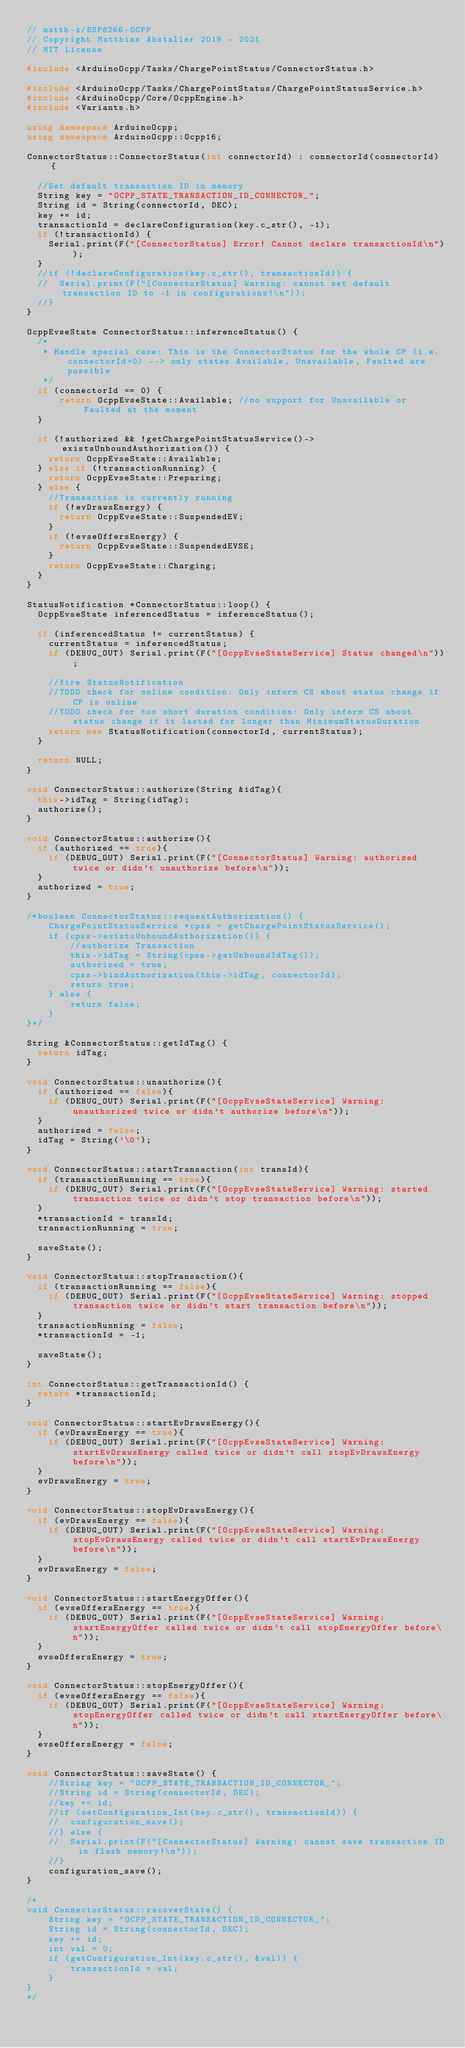Convert code to text. <code><loc_0><loc_0><loc_500><loc_500><_C++_>// matth-x/ESP8266-OCPP
// Copyright Matthias Akstaller 2019 - 2021
// MIT License

#include <ArduinoOcpp/Tasks/ChargePointStatus/ConnectorStatus.h>

#include <ArduinoOcpp/Tasks/ChargePointStatus/ChargePointStatusService.h>
#include <ArduinoOcpp/Core/OcppEngine.h>
#include <Variants.h>

using namespace ArduinoOcpp;
using namespace ArduinoOcpp::Ocpp16;

ConnectorStatus::ConnectorStatus(int connectorId) : connectorId(connectorId) {

  //Set default transaction ID in memory
  String key = "OCPP_STATE_TRANSACTION_ID_CONNECTOR_";
  String id = String(connectorId, DEC);
  key += id;
  transactionId = declareConfiguration(key.c_str(), -1);
  if (!transactionId) {
    Serial.print(F("[ConnectorStatus] Error! Cannot declare transactionId\n"));
  }
  //if (!declareConfiguration(key.c_str(), transactionId)) {
  //  Serial.print(F("[ConnectorStatus] Warning: cannot set default transaction ID to -1 in configurations!\n"));
  //}
}

OcppEvseState ConnectorStatus::inferenceStatus() {
  /*
   * Handle special case: This is the ConnectorStatus for the whole CP (i.e. connectorId=0) --> only states Available, Unavailable, Faulted are possible
   */
  if (connectorId == 0) {
      return OcppEvseState::Available; //no support for Unavailable or Faulted at the moment
  }

  if (!authorized && !getChargePointStatusService()->existsUnboundAuthorization()) {
    return OcppEvseState::Available;
  } else if (!transactionRunning) {
    return OcppEvseState::Preparing;
  } else {
    //Transaction is currently running
    if (!evDrawsEnergy) {
      return OcppEvseState::SuspendedEV;
    }
    if (!evseOffersEnergy) {
      return OcppEvseState::SuspendedEVSE;
    }
    return OcppEvseState::Charging;
  }
}

StatusNotification *ConnectorStatus::loop() {
  OcppEvseState inferencedStatus = inferenceStatus();
  
  if (inferencedStatus != currentStatus) {
    currentStatus = inferencedStatus;
    if (DEBUG_OUT) Serial.print(F("[OcppEvseStateService] Status changed\n"));

    //fire StatusNotification
    //TODO check for online condition: Only inform CS about status change if CP is online
    //TODO check for too short duration condition: Only inform CS about status change if it lasted for longer than MinimumStatusDuration
    return new StatusNotification(connectorId, currentStatus);
  }

  return NULL;
}

void ConnectorStatus::authorize(String &idTag){
  this->idTag = String(idTag);
  authorize();
}

void ConnectorStatus::authorize(){
  if (authorized == true){
    if (DEBUG_OUT) Serial.print(F("[ConnectorStatus] Warning: authorized twice or didn't unauthorize before\n"));
  }
  authorized = true;
}

/*boolean ConnectorStatus::requestAuthorization() {
    ChargePointStatusService *cpss = getChargePointStatusService();
    if (cpss->existsUnboundAuthorization()) {
        //authorize Transaction
        this->idTag = String(cpss->getUnboundIdTag());
        authorized = true;
        cpss->bindAuthorization(this->idTag, connectorId);
        return true;
    } else {
        return false;
    }
}*/

String &ConnectorStatus::getIdTag() {
  return idTag;
}

void ConnectorStatus::unauthorize(){
  if (authorized == false){
    if (DEBUG_OUT) Serial.print(F("[OcppEvseStateService] Warning: unauthorized twice or didn't authorize before\n"));
  }
  authorized = false;
  idTag = String('\0');
}

void ConnectorStatus::startTransaction(int transId){
  if (transactionRunning == true){
    if (DEBUG_OUT) Serial.print(F("[OcppEvseStateService] Warning: started transaction twice or didn't stop transaction before\n"));
  }
  *transactionId = transId;
  transactionRunning = true;

  saveState();
}

void ConnectorStatus::stopTransaction(){
  if (transactionRunning == false){
    if (DEBUG_OUT) Serial.print(F("[OcppEvseStateService] Warning: stopped transaction twice or didn't start transaction before\n"));
  }
  transactionRunning = false;
  *transactionId = -1;

  saveState();
}

int ConnectorStatus::getTransactionId() {
  return *transactionId;
}

void ConnectorStatus::startEvDrawsEnergy(){
  if (evDrawsEnergy == true){
    if (DEBUG_OUT) Serial.print(F("[OcppEvseStateService] Warning: startEvDrawsEnergy called twice or didn't call stopEvDrawsEnergy before\n"));
  }
  evDrawsEnergy = true;
}

void ConnectorStatus::stopEvDrawsEnergy(){
  if (evDrawsEnergy == false){
    if (DEBUG_OUT) Serial.print(F("[OcppEvseStateService] Warning: stopEvDrawsEnergy called twice or didn't call startEvDrawsEnergy before\n"));
  }
  evDrawsEnergy = false;
}

void ConnectorStatus::startEnergyOffer(){
  if (evseOffersEnergy == true){
    if (DEBUG_OUT) Serial.print(F("[OcppEvseStateService] Warning: startEnergyOffer called twice or didn't call stopEnergyOffer before\n"));
  }
  evseOffersEnergy = true;
}

void ConnectorStatus::stopEnergyOffer(){
  if (evseOffersEnergy == false){
    if (DEBUG_OUT) Serial.print(F("[OcppEvseStateService] Warning: stopEnergyOffer called twice or didn't call startEnergyOffer before\n"));
  }
  evseOffersEnergy = false;
}

void ConnectorStatus::saveState() {
    //String key = "OCPP_STATE_TRANSACTION_ID_CONNECTOR_";
    //String id = String(connectorId, DEC);
    //key += id;
    //if (setConfiguration_Int(key.c_str(), transactionId)) {
    //  configuration_save();
    //} else {
    //  Serial.print(F("[ConnectorStatus] Warning: cannot save transaction ID in flash memory!\n"));
    //}
    configuration_save();
}

/*
void ConnectorStatus::recoverState() {
    String key = "OCPP_STATE_TRANSACTION_ID_CONNECTOR_";
    String id = String(connectorId, DEC);
    key += id;
    int val = 0;
    if (getConfiguration_Int(key.c_str(), &val)) {
        transactionId = val;
    }
}
*/
</code> 